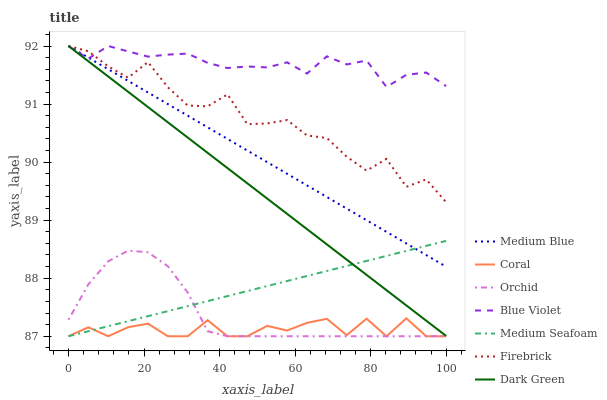Does Coral have the minimum area under the curve?
Answer yes or no. Yes. Does Blue Violet have the maximum area under the curve?
Answer yes or no. Yes. Does Medium Blue have the minimum area under the curve?
Answer yes or no. No. Does Medium Blue have the maximum area under the curve?
Answer yes or no. No. Is Dark Green the smoothest?
Answer yes or no. Yes. Is Firebrick the roughest?
Answer yes or no. Yes. Is Medium Blue the smoothest?
Answer yes or no. No. Is Medium Blue the roughest?
Answer yes or no. No. Does Medium Blue have the lowest value?
Answer yes or no. No. Does Medium Seafoam have the highest value?
Answer yes or no. No. Is Orchid less than Medium Blue?
Answer yes or no. Yes. Is Blue Violet greater than Coral?
Answer yes or no. Yes. Does Orchid intersect Medium Blue?
Answer yes or no. No. 